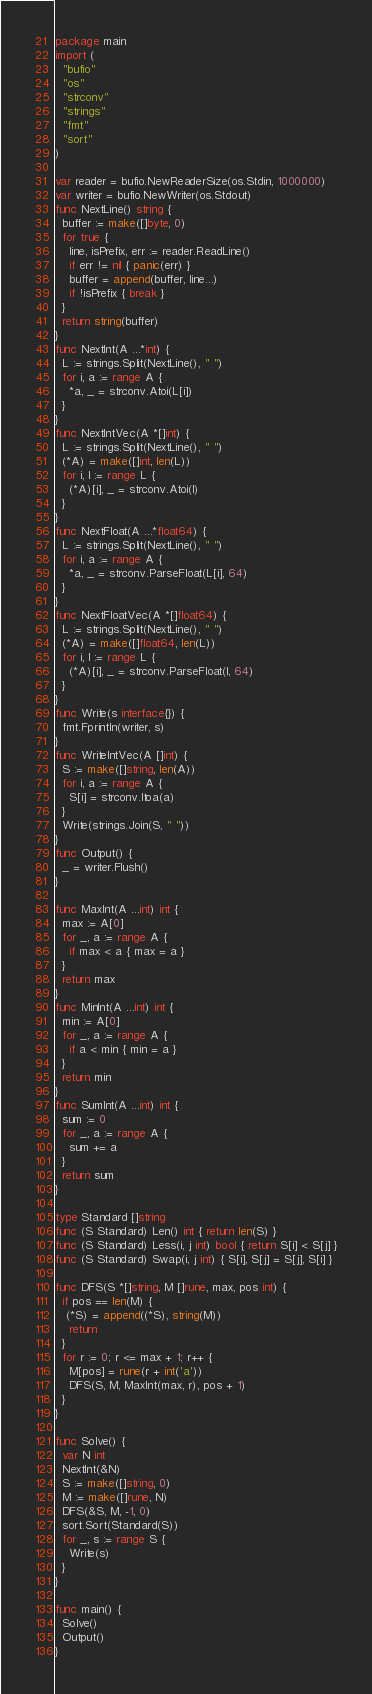Convert code to text. <code><loc_0><loc_0><loc_500><loc_500><_Go_>package main
import (
  "bufio"
  "os"
  "strconv"
  "strings"
  "fmt"
  "sort"
)

var reader = bufio.NewReaderSize(os.Stdin, 1000000)
var writer = bufio.NewWriter(os.Stdout)
func NextLine() string {
  buffer := make([]byte, 0)
  for true {
    line, isPrefix, err := reader.ReadLine()
    if err != nil { panic(err) }
    buffer = append(buffer, line...)
    if !isPrefix { break }
  }
  return string(buffer)
}
func NextInt(A ...*int) {
  L := strings.Split(NextLine(), " ")
  for i, a := range A {
    *a, _ = strconv.Atoi(L[i])
  }
}
func NextIntVec(A *[]int) {
  L := strings.Split(NextLine(), " ")
  (*A) = make([]int, len(L))
  for i, l := range L {
    (*A)[i], _ = strconv.Atoi(l)
  }
}
func NextFloat(A ...*float64) {
  L := strings.Split(NextLine(), " ")
  for i, a := range A {
    *a, _ = strconv.ParseFloat(L[i], 64)
  }
}
func NextFloatVec(A *[]float64) {
  L := strings.Split(NextLine(), " ")
  (*A) = make([]float64, len(L))
  for i, l := range L {
    (*A)[i], _ = strconv.ParseFloat(l, 64)
  }
}
func Write(s interface{}) {
  fmt.Fprintln(writer, s)
}
func WriteIntVec(A []int) {
  S := make([]string, len(A))
  for i, a := range A {
    S[i] = strconv.Itoa(a)
  }
  Write(strings.Join(S, " "))
}
func Output() {
  _ = writer.Flush()
}

func MaxInt(A ...int) int {
  max := A[0]
  for _, a := range A {
    if max < a { max = a }
  }
  return max
}
func MinInt(A ...int) int {
  min := A[0]
  for _, a := range A {
    if a < min { min = a }
  }
  return min
}
func SumInt(A ...int) int {
  sum := 0
  for _, a := range A {
    sum += a
  }
  return sum
}

type Standard []string
func (S Standard) Len() int { return len(S) }
func (S Standard) Less(i, j int) bool { return S[i] < S[j] }
func (S Standard) Swap(i, j int) { S[i], S[j] = S[j], S[i] }

func DFS(S *[]string, M []rune, max, pos int) {
  if pos == len(M) {
   (*S) = append((*S), string(M))
    return
  }
  for r := 0; r <= max + 1; r++ {
    M[pos] = rune(r + int('a'))
    DFS(S, M, MaxInt(max, r), pos + 1)
  }
}

func Solve() {
  var N int
  NextInt(&N)
  S := make([]string, 0)
  M := make([]rune, N)
  DFS(&S, M, -1, 0)
  sort.Sort(Standard(S))
  for _, s := range S {
    Write(s)
  }
}

func main() {
  Solve()
  Output()
}</code> 